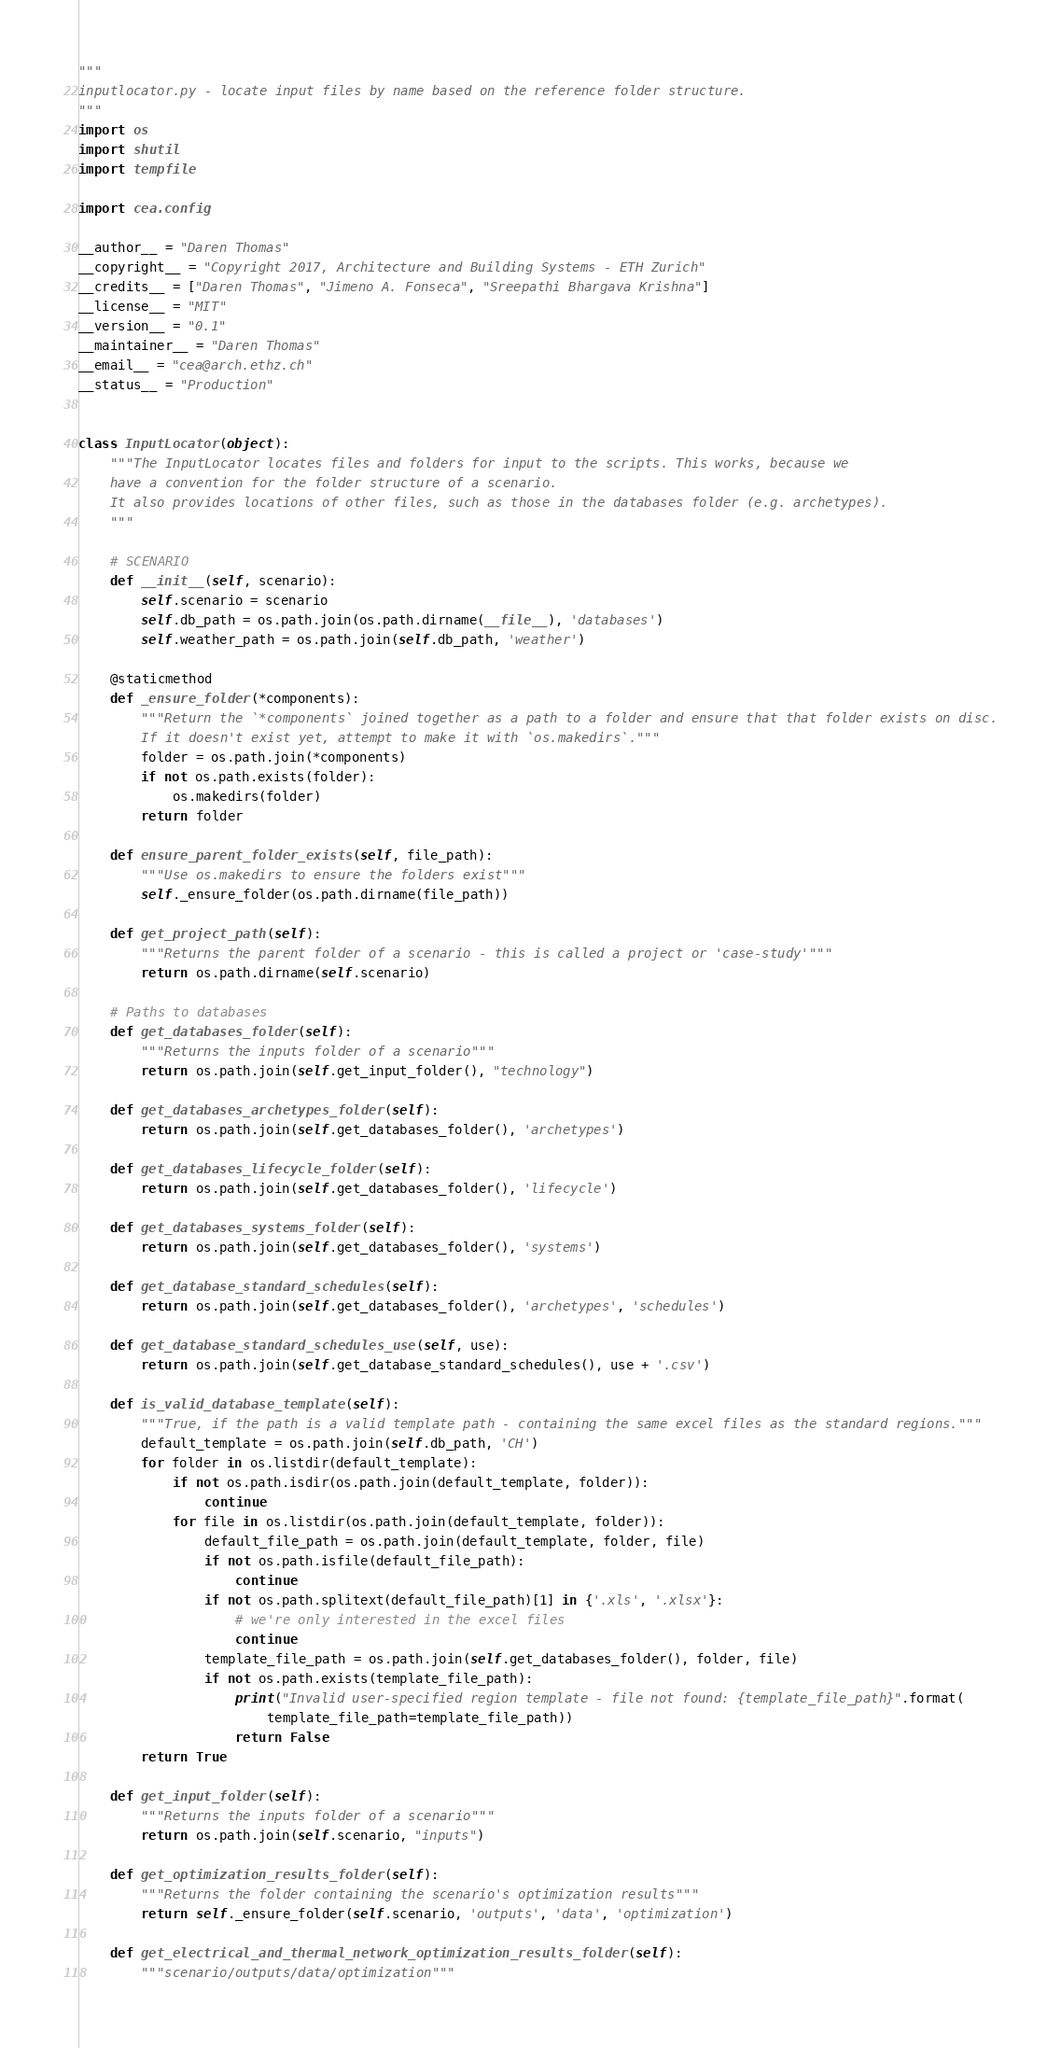<code> <loc_0><loc_0><loc_500><loc_500><_Python_>"""
inputlocator.py - locate input files by name based on the reference folder structure.
"""
import os
import shutil
import tempfile

import cea.config

__author__ = "Daren Thomas"
__copyright__ = "Copyright 2017, Architecture and Building Systems - ETH Zurich"
__credits__ = ["Daren Thomas", "Jimeno A. Fonseca", "Sreepathi Bhargava Krishna"]
__license__ = "MIT"
__version__ = "0.1"
__maintainer__ = "Daren Thomas"
__email__ = "cea@arch.ethz.ch"
__status__ = "Production"


class InputLocator(object):
    """The InputLocator locates files and folders for input to the scripts. This works, because we
    have a convention for the folder structure of a scenario.
    It also provides locations of other files, such as those in the databases folder (e.g. archetypes).
    """

    # SCENARIO
    def __init__(self, scenario):
        self.scenario = scenario
        self.db_path = os.path.join(os.path.dirname(__file__), 'databases')
        self.weather_path = os.path.join(self.db_path, 'weather')

    @staticmethod
    def _ensure_folder(*components):
        """Return the `*components` joined together as a path to a folder and ensure that that folder exists on disc.
        If it doesn't exist yet, attempt to make it with `os.makedirs`."""
        folder = os.path.join(*components)
        if not os.path.exists(folder):
            os.makedirs(folder)
        return folder

    def ensure_parent_folder_exists(self, file_path):
        """Use os.makedirs to ensure the folders exist"""
        self._ensure_folder(os.path.dirname(file_path))

    def get_project_path(self):
        """Returns the parent folder of a scenario - this is called a project or 'case-study'"""
        return os.path.dirname(self.scenario)

    # Paths to databases
    def get_databases_folder(self):
        """Returns the inputs folder of a scenario"""
        return os.path.join(self.get_input_folder(), "technology")

    def get_databases_archetypes_folder(self):
        return os.path.join(self.get_databases_folder(), 'archetypes')

    def get_databases_lifecycle_folder(self):
        return os.path.join(self.get_databases_folder(), 'lifecycle')

    def get_databases_systems_folder(self):
        return os.path.join(self.get_databases_folder(), 'systems')

    def get_database_standard_schedules(self):
        return os.path.join(self.get_databases_folder(), 'archetypes', 'schedules')

    def get_database_standard_schedules_use(self, use):
        return os.path.join(self.get_database_standard_schedules(), use + '.csv')

    def is_valid_database_template(self):
        """True, if the path is a valid template path - containing the same excel files as the standard regions."""
        default_template = os.path.join(self.db_path, 'CH')
        for folder in os.listdir(default_template):
            if not os.path.isdir(os.path.join(default_template, folder)):
                continue
            for file in os.listdir(os.path.join(default_template, folder)):
                default_file_path = os.path.join(default_template, folder, file)
                if not os.path.isfile(default_file_path):
                    continue
                if not os.path.splitext(default_file_path)[1] in {'.xls', '.xlsx'}:
                    # we're only interested in the excel files
                    continue
                template_file_path = os.path.join(self.get_databases_folder(), folder, file)
                if not os.path.exists(template_file_path):
                    print("Invalid user-specified region template - file not found: {template_file_path}".format(
                        template_file_path=template_file_path))
                    return False
        return True

    def get_input_folder(self):
        """Returns the inputs folder of a scenario"""
        return os.path.join(self.scenario, "inputs")

    def get_optimization_results_folder(self):
        """Returns the folder containing the scenario's optimization results"""
        return self._ensure_folder(self.scenario, 'outputs', 'data', 'optimization')

    def get_electrical_and_thermal_network_optimization_results_folder(self):
        """scenario/outputs/data/optimization"""</code> 